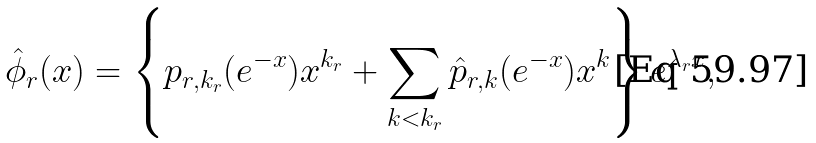Convert formula to latex. <formula><loc_0><loc_0><loc_500><loc_500>\hat { \phi } _ { r } ( x ) = \left \{ p _ { r , k _ { r } } ( e ^ { - x } ) x ^ { k _ { r } } + \sum _ { k < k _ { r } } \hat { p } _ { r , k } ( e ^ { - x } ) x ^ { k } \right \} e ^ { \lambda _ { r } x } ,</formula> 